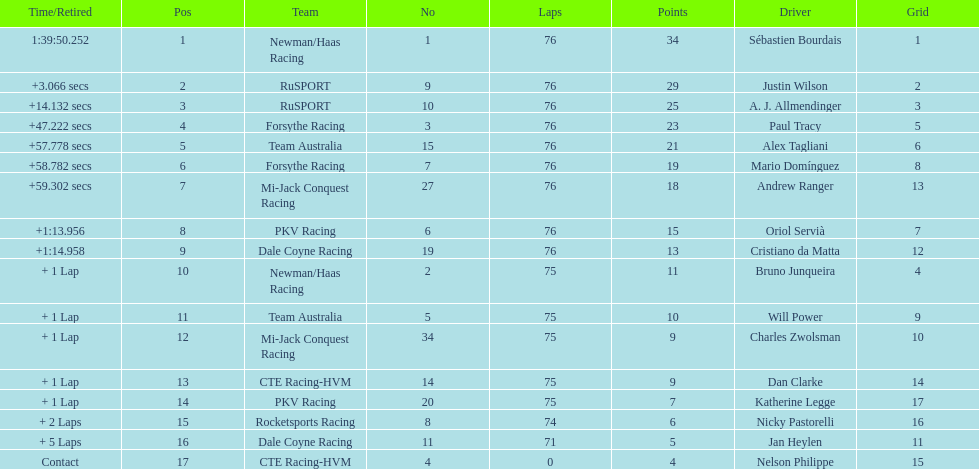What drivers took part in the 2006 tecate grand prix of monterrey? Sébastien Bourdais, Justin Wilson, A. J. Allmendinger, Paul Tracy, Alex Tagliani, Mario Domínguez, Andrew Ranger, Oriol Servià, Cristiano da Matta, Bruno Junqueira, Will Power, Charles Zwolsman, Dan Clarke, Katherine Legge, Nicky Pastorelli, Jan Heylen, Nelson Philippe. Which of those drivers scored the same amount of points as another driver? Charles Zwolsman, Dan Clarke. Who had the same amount of points as charles zwolsman? Dan Clarke. 